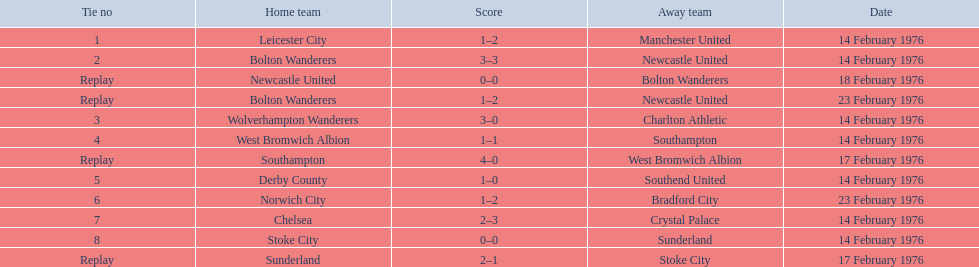What were the home teams in the 1975-76 fa cup? Leicester City, Bolton Wanderers, Newcastle United, Bolton Wanderers, Wolverhampton Wanderers, West Bromwich Albion, Southampton, Derby County, Norwich City, Chelsea, Stoke City, Sunderland. Which of these teams had the tie number 1? Leicester City. 